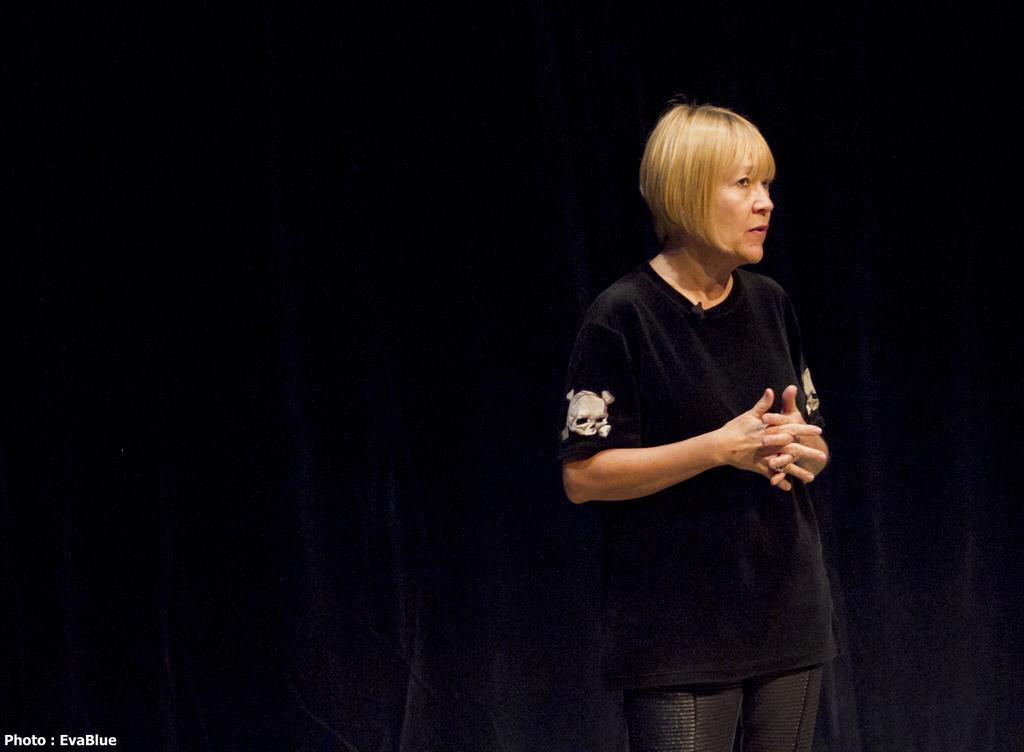Who is present in the image? There is a woman in the image. What is the woman doing in the image? The woman is standing. What is the opinion of the turkey in the image? There is no turkey present in the image, so it is not possible to determine its opinion. 